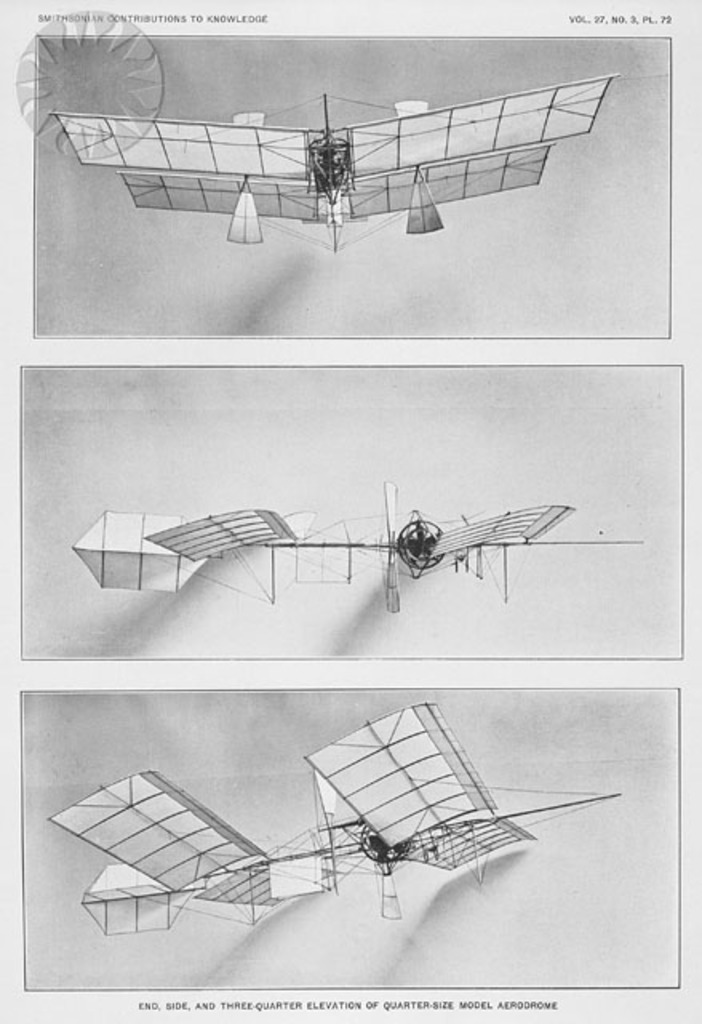Can you describe the type of research or experimentation this model aerodrome was likely used for? This quarter-size aerodrome model was likely used for fundamental aerodynamic research, specifically studying the effects of wing configuration, strut arrangements, and airfoil shapes on flight stability and control. Such models were essential for safely testing theories in wind tunnels or controlled flight situations before full-scale manufacturing or manned flights. 